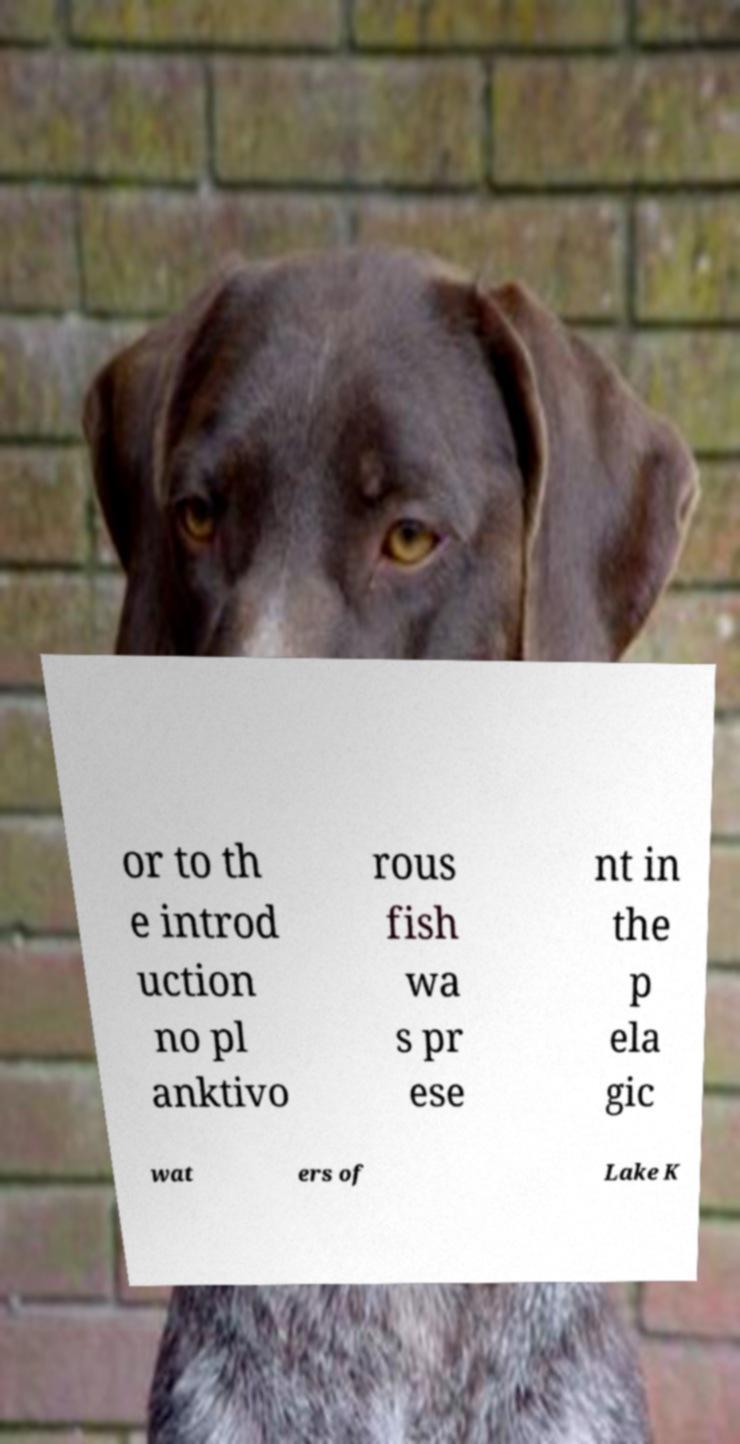Can you accurately transcribe the text from the provided image for me? or to th e introd uction no pl anktivo rous fish wa s pr ese nt in the p ela gic wat ers of Lake K 